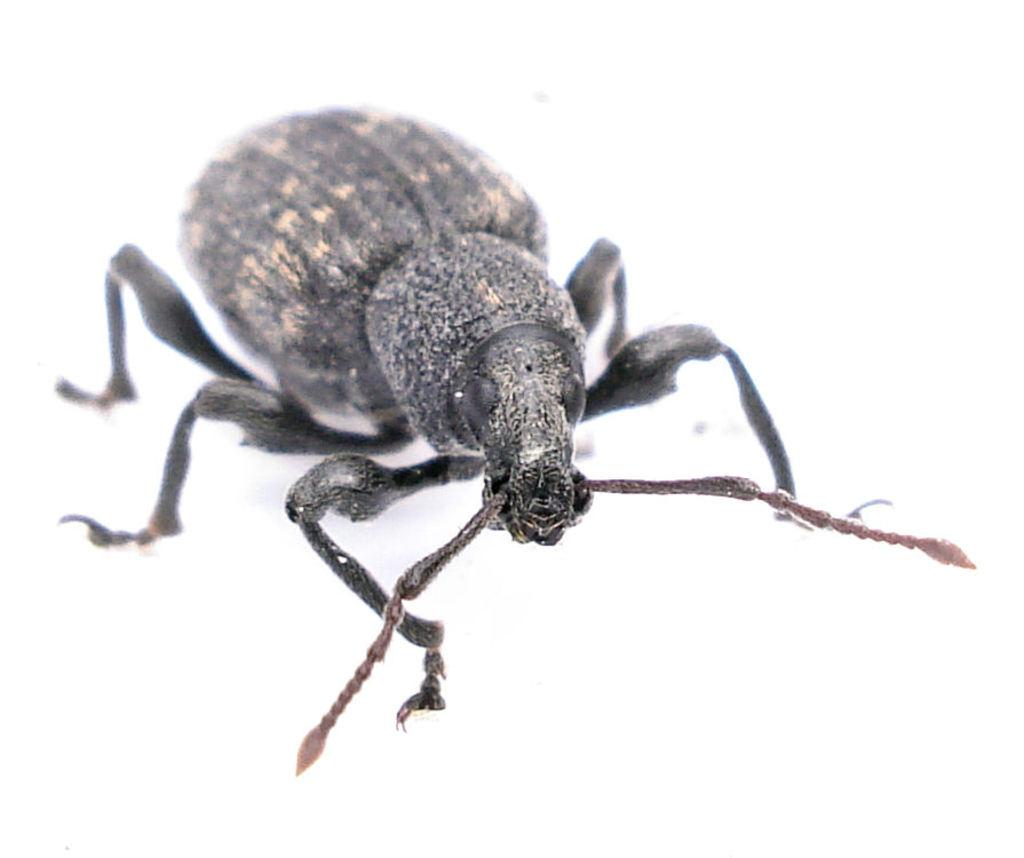What type of creature can be seen in the image? There is an insect in the image. What is the color of the surface where the insect is located? The insect is on a white-colored surface. What does the insect hope to achieve in the image? There is no indication in the image that the insect has any specific hopes or goals. 